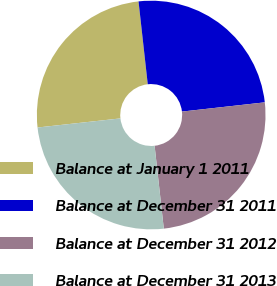Convert chart. <chart><loc_0><loc_0><loc_500><loc_500><pie_chart><fcel>Balance at January 1 2011<fcel>Balance at December 31 2011<fcel>Balance at December 31 2012<fcel>Balance at December 31 2013<nl><fcel>24.98%<fcel>25.0%<fcel>25.01%<fcel>25.02%<nl></chart> 